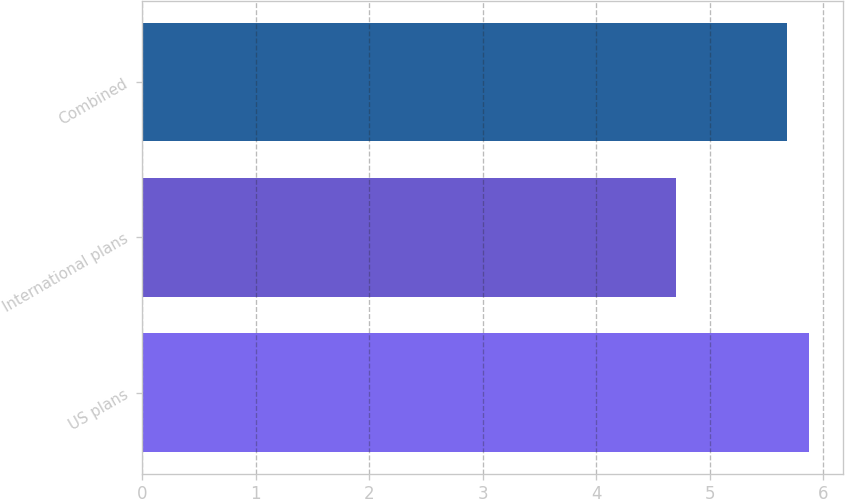Convert chart. <chart><loc_0><loc_0><loc_500><loc_500><bar_chart><fcel>US plans<fcel>International plans<fcel>Combined<nl><fcel>5.88<fcel>4.7<fcel>5.68<nl></chart> 